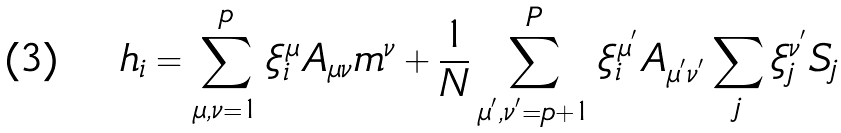<formula> <loc_0><loc_0><loc_500><loc_500>h _ { i } = \sum _ { \mu , \nu = 1 } ^ { p } \xi _ { i } ^ { \mu } A _ { \mu \nu } m ^ { \nu } + \frac { 1 } { N } \sum _ { \mu ^ { ^ { \prime } } , \nu ^ { ^ { \prime } } = p + 1 } ^ { P } \xi _ { i } ^ { \mu ^ { ^ { \prime } } } A _ { \mu ^ { ^ { \prime } } \nu ^ { ^ { \prime } } } \sum _ { j } \xi _ { j } ^ { \nu ^ { ^ { \prime } } } S _ { j }</formula> 